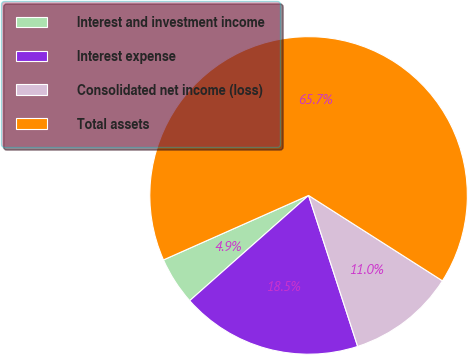Convert chart to OTSL. <chart><loc_0><loc_0><loc_500><loc_500><pie_chart><fcel>Interest and investment income<fcel>Interest expense<fcel>Consolidated net income (loss)<fcel>Total assets<nl><fcel>4.88%<fcel>18.47%<fcel>10.96%<fcel>65.69%<nl></chart> 